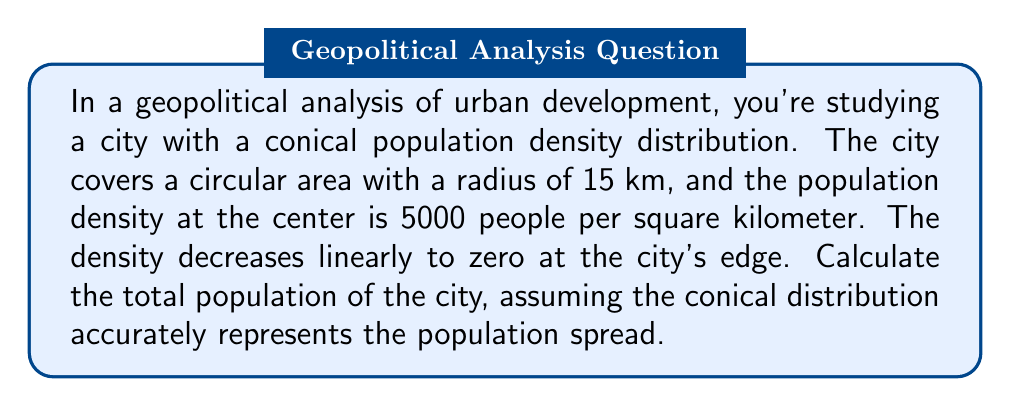Give your solution to this math problem. To solve this problem, we need to calculate the volume of a cone, where the height represents population density and the base represents the city area. Here's how we can approach this:

1) The cone's base radius is 15 km.

2) The cone's height is 5000 people/km².

3) The volume of a cone is given by the formula:

   $$V = \frac{1}{3}\pi r^2 h$$

   Where $r$ is the radius of the base and $h$ is the height.

4) Substituting our values:

   $$V = \frac{1}{3}\pi (15\text{ km})^2 (5000\text{ people/km}^2)$$

5) Simplify:

   $$V = \frac{1}{3}\pi (225\text{ km}^2) (5000\text{ people/km}^2)$$

6) Calculate:

   $$V = 1178097.2454\text{ people}$$

7) Round to the nearest whole number, as we can't have a fraction of a person.

Note: The units work out because km² in the base cancels with km² in the height, leaving us with just people.

This volume represents the total population of the city.

[asy]
import graph;
size(200);
real f(real x) {return 5000*(1-x/15);}
fill((0,0)--(15,0)--graph(f,0,15)--cycle,gray(0.8));
draw((0,0)--(15,0));
draw((0,0)--graph(f,0,15));
draw((15,0)--graph(f,15,15));
label("15 km",(7.5,0),S);
label("5000 people/km²",(0,5000),W);
[/asy]
Answer: The total population of the city is approximately 1,178,097 people. 